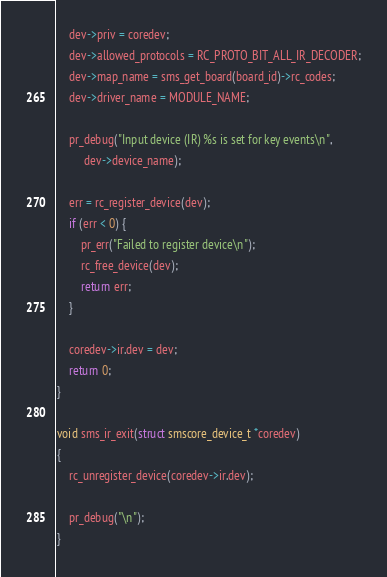Convert code to text. <code><loc_0><loc_0><loc_500><loc_500><_C_>	dev->priv = coredev;
	dev->allowed_protocols = RC_PROTO_BIT_ALL_IR_DECODER;
	dev->map_name = sms_get_board(board_id)->rc_codes;
	dev->driver_name = MODULE_NAME;

	pr_debug("Input device (IR) %s is set for key events\n",
		 dev->device_name);

	err = rc_register_device(dev);
	if (err < 0) {
		pr_err("Failed to register device\n");
		rc_free_device(dev);
		return err;
	}

	coredev->ir.dev = dev;
	return 0;
}

void sms_ir_exit(struct smscore_device_t *coredev)
{
	rc_unregister_device(coredev->ir.dev);

	pr_debug("\n");
}
</code> 